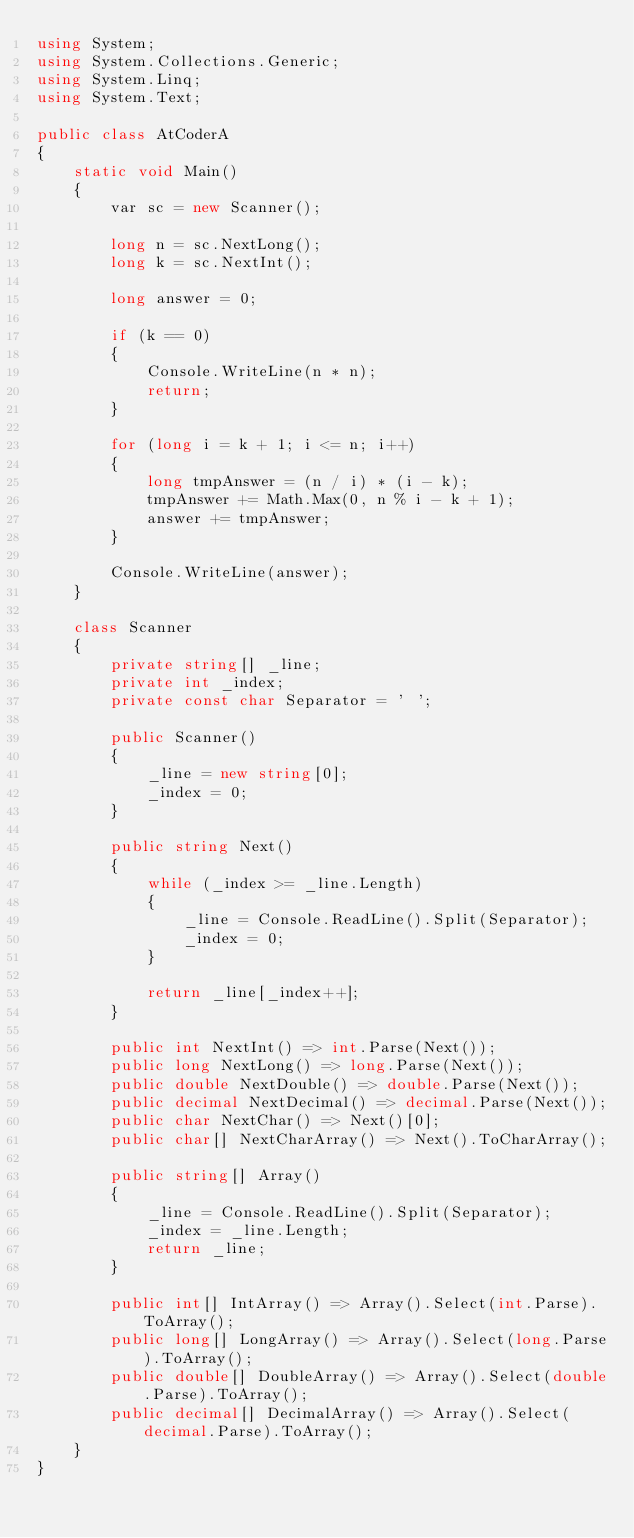Convert code to text. <code><loc_0><loc_0><loc_500><loc_500><_C#_>using System;
using System.Collections.Generic;
using System.Linq;
using System.Text;

public class AtCoderA
{
    static void Main()
    {
        var sc = new Scanner();

        long n = sc.NextLong();
        long k = sc.NextInt();

        long answer = 0;

        if (k == 0)
        {
            Console.WriteLine(n * n);
            return;
        }

        for (long i = k + 1; i <= n; i++)
        {
            long tmpAnswer = (n / i) * (i - k);
            tmpAnswer += Math.Max(0, n % i - k + 1);
            answer += tmpAnswer;
        }

        Console.WriteLine(answer);
    }

    class Scanner
    {
        private string[] _line;
        private int _index;
        private const char Separator = ' ';

        public Scanner()
        {
            _line = new string[0];
            _index = 0;
        }

        public string Next()
        {
            while (_index >= _line.Length)
            {
                _line = Console.ReadLine().Split(Separator);
                _index = 0;
            }

            return _line[_index++];
        }

        public int NextInt() => int.Parse(Next());
        public long NextLong() => long.Parse(Next());
        public double NextDouble() => double.Parse(Next());
        public decimal NextDecimal() => decimal.Parse(Next());
        public char NextChar() => Next()[0];
        public char[] NextCharArray() => Next().ToCharArray();

        public string[] Array()
        {
            _line = Console.ReadLine().Split(Separator);
            _index = _line.Length;
            return _line;
        }

        public int[] IntArray() => Array().Select(int.Parse).ToArray();
        public long[] LongArray() => Array().Select(long.Parse).ToArray();
        public double[] DoubleArray() => Array().Select(double.Parse).ToArray();
        public decimal[] DecimalArray() => Array().Select(decimal.Parse).ToArray();
    }
}
</code> 